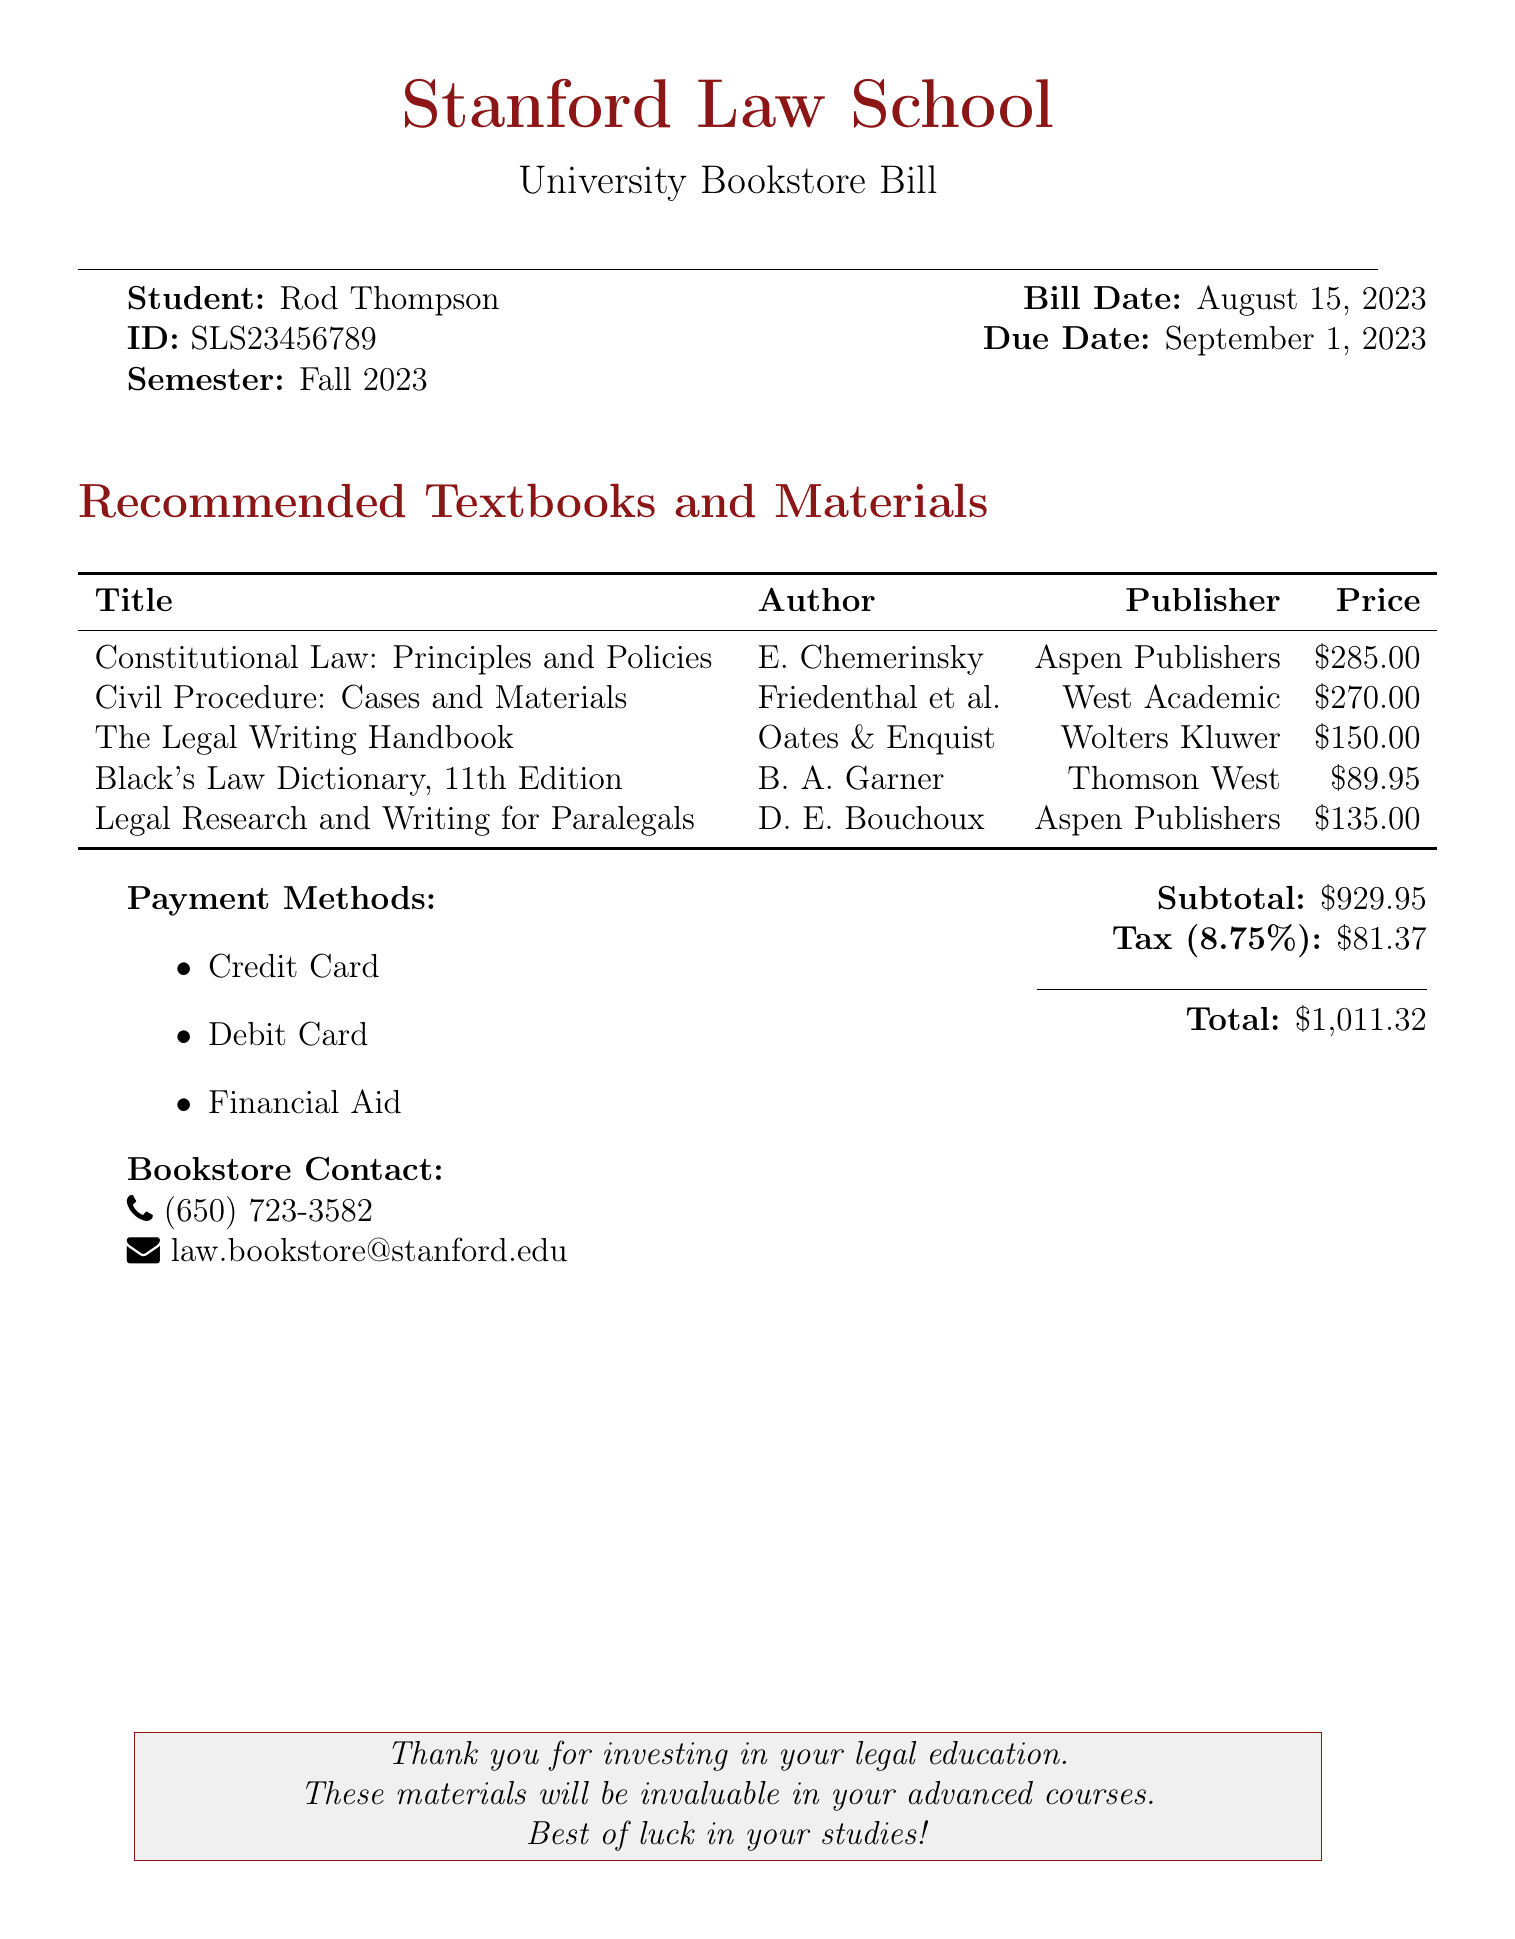What is the name of the student? The name of the student is listed at the beginning of the document.
Answer: Rod Thompson What is the total amount due? The total amount due is displayed in the billing section of the document.
Answer: $1,011.32 Who is the author of "Constitutional Law: Principles and Policies"? The author's name is provided alongside the title in the recommended materials section.
Answer: E. Chemerinsky What is the publisher of "The Legal Writing Handbook"? The publisher of the book is mentioned in the same line as the title and author.
Answer: Wolters Kluwer What is the tax rate applied to the subtotal? The tax rate is stated in the document under the billing summary section.
Answer: 8.75% What payment methods are accepted? The document lists the available payment options in a designated section.
Answer: Credit Card, Debit Card, Financial Aid What is the bill date? The bill date is presented in the header section of the document.
Answer: August 15, 2023 What is the due date for the bill? The due date is mentioned directly in the same header section as the bill date.
Answer: September 1, 2023 How many recommended textbooks are listed? The total count can be determined by counting the entries under the recommended materials.
Answer: 5 